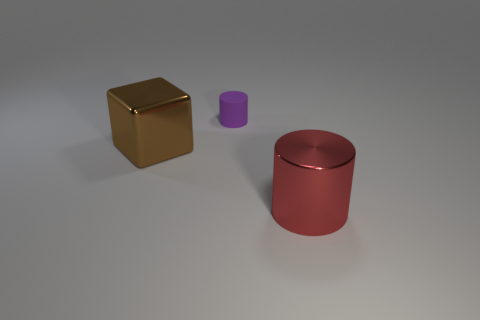Add 3 big shiny things. How many objects exist? 6 Subtract all blocks. How many objects are left? 2 Add 3 big red metal cylinders. How many big red metal cylinders exist? 4 Subtract 0 cyan blocks. How many objects are left? 3 Subtract all small blue metallic cubes. Subtract all tiny purple rubber objects. How many objects are left? 2 Add 1 tiny purple matte objects. How many tiny purple matte objects are left? 2 